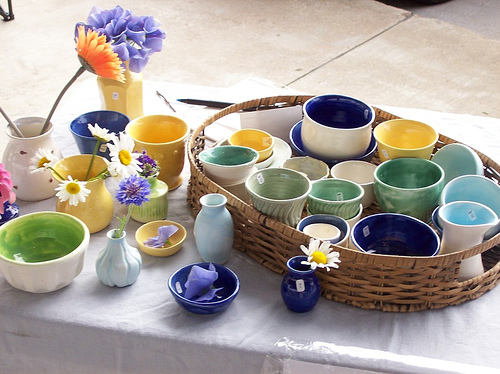<image>Which bowl has the most flowers in it? It's ambiguous which bowl has the most flowers. It could be the yellow one or the tall white one. Which bowl has the most flowers in it? I'm not sure which bowl has the most flowers in it. 